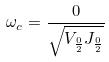<formula> <loc_0><loc_0><loc_500><loc_500>\omega _ { c } = \frac { 0 } { \sqrt { V _ { \frac { 0 } { 2 } } J _ { \frac { 0 } { 2 } } } }</formula> 